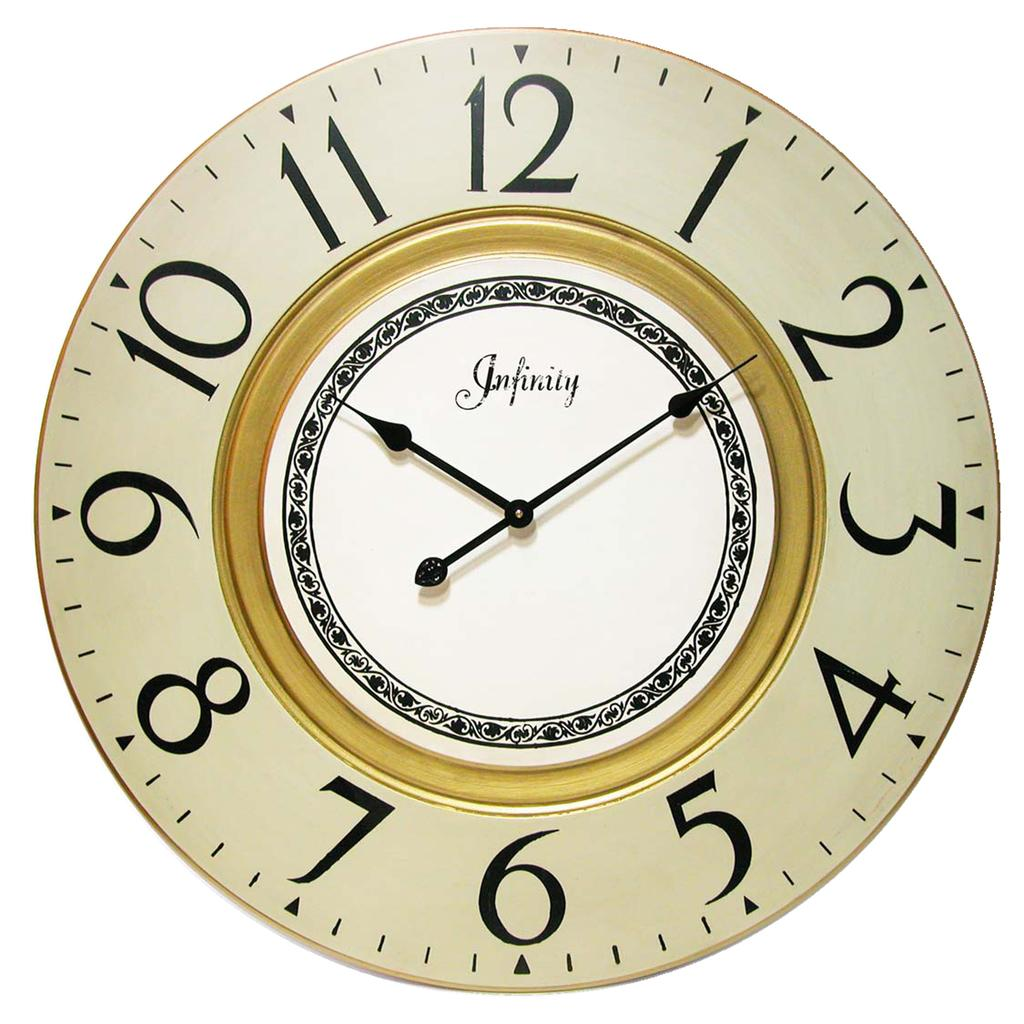<image>
Render a clear and concise summary of the photo. An Infinity clock says that the time is 10:09. 